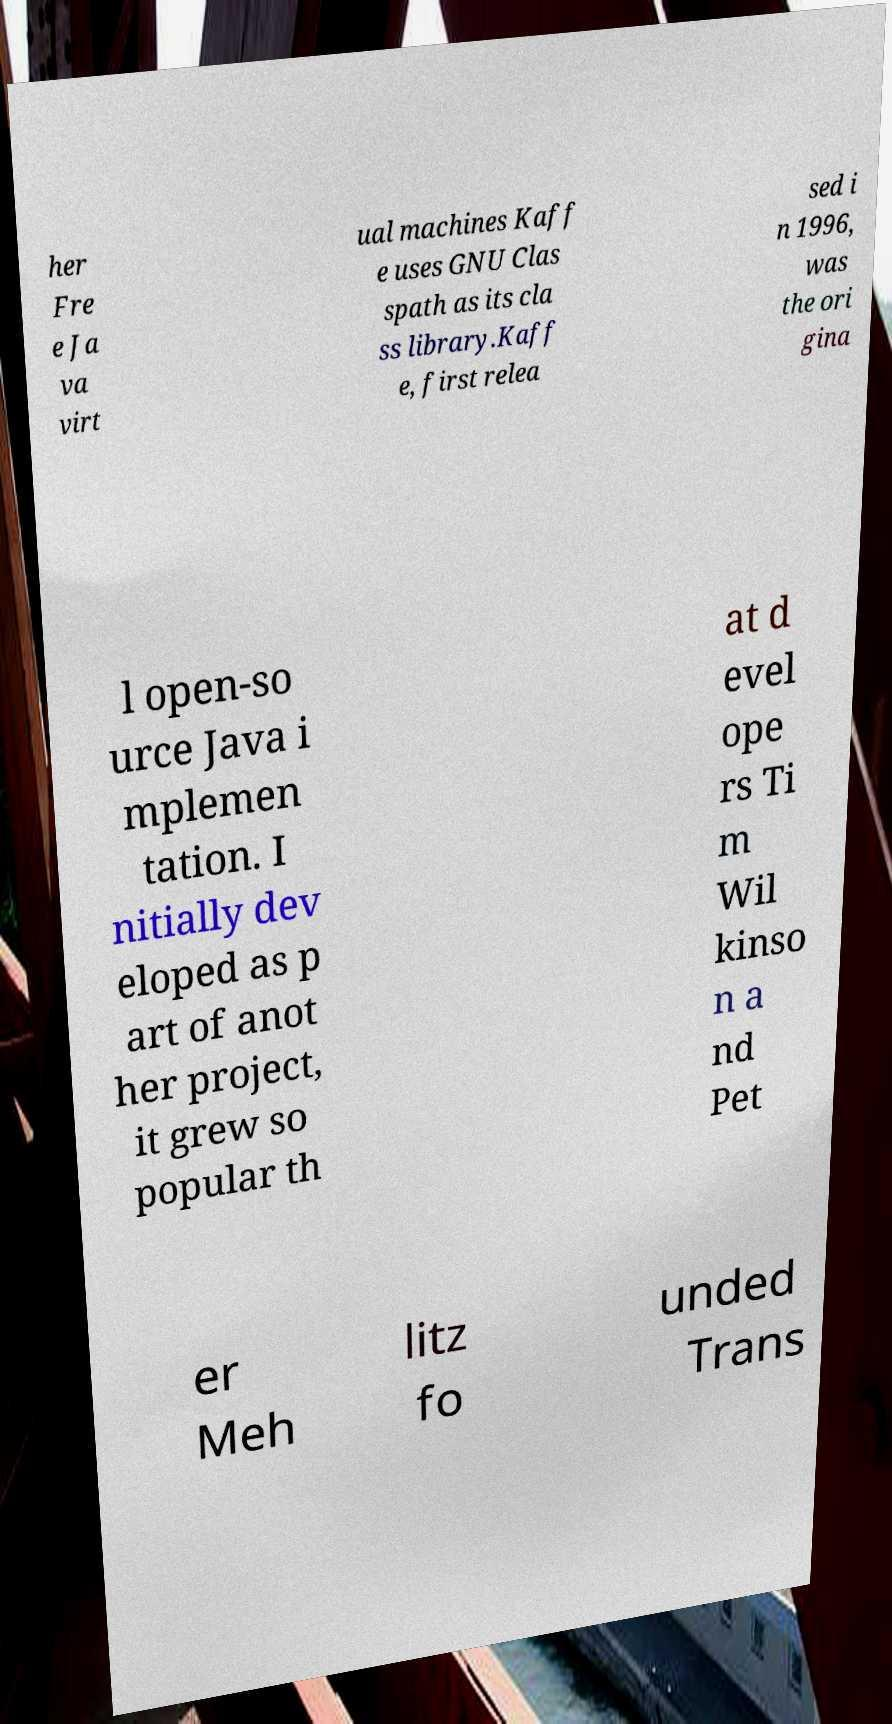There's text embedded in this image that I need extracted. Can you transcribe it verbatim? her Fre e Ja va virt ual machines Kaff e uses GNU Clas spath as its cla ss library.Kaff e, first relea sed i n 1996, was the ori gina l open-so urce Java i mplemen tation. I nitially dev eloped as p art of anot her project, it grew so popular th at d evel ope rs Ti m Wil kinso n a nd Pet er Meh litz fo unded Trans 